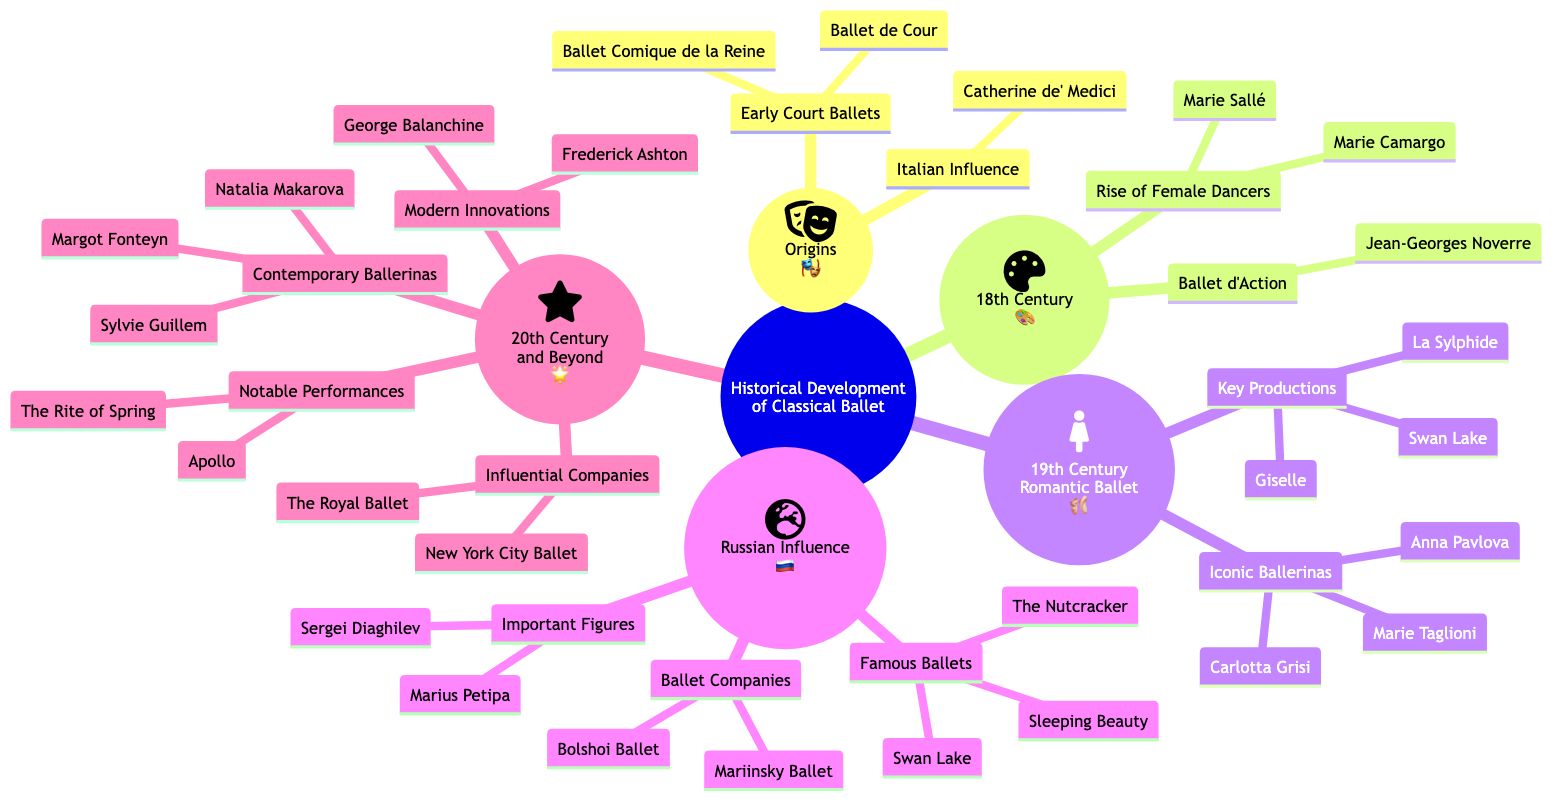What are two key productions in the 19th Century Romantic Ballet? The diagram lists "La Sylphide" and "Giselle" as key productions in the 19th Century Romantic Ballet section.
Answer: La Sylphide, Giselle Who is an important figure from the Russian Influence section? The diagram mentions "Marius Petipa" and "Sergei Diaghilev" as important figures in the Russian Influence section.
Answer: Marius Petipa What major innovation came from George Balanchine? The diagram notes "Modern Innovations" associated with George Balanchine in the 20th Century and Beyond section.
Answer: Modern Innovations How many iconic ballerinas are listed under the 19th Century Romantic Ballet? Under the 19th Century Romantic Ballet section, there are three iconic ballerinas: "Marie Taglioni," "Carlotta Grisi," and "Anna Pavlova." Therefore, the count is three.
Answer: 3 What is the relationship between "Swan Lake" and "19th Century Romantic Ballet"? The diagram shows that "Swan Lake" is positioned as a key production in both the "19th Century Romantic Ballet" and "Russian Influence" sections, indicating a cross-reference of its significance.
Answer: Key production What period is recognized for the rise of female dancers? The diagram indicates the "Rise of Female Dancers" occurred during the 18th Century.
Answer: 18th Century Which ballet companies are indicated in the Russian Influence section? The diagram lists "Mariinsky Ballet" and "Bolshoi Ballet" as ballet companies under the Russian Influence section, pointing to their significance.
Answer: Mariinsky Ballet, Bolshoi Ballet Which two ballerinas are known from the 20th Century and Beyond period? The diagram highlights "Margot Fonteyn" and "Sylvie Guillem" as notable contemporary ballerinas in the 20th Century and Beyond section.
Answer: Margot Fonteyn, Sylvie Guillem 